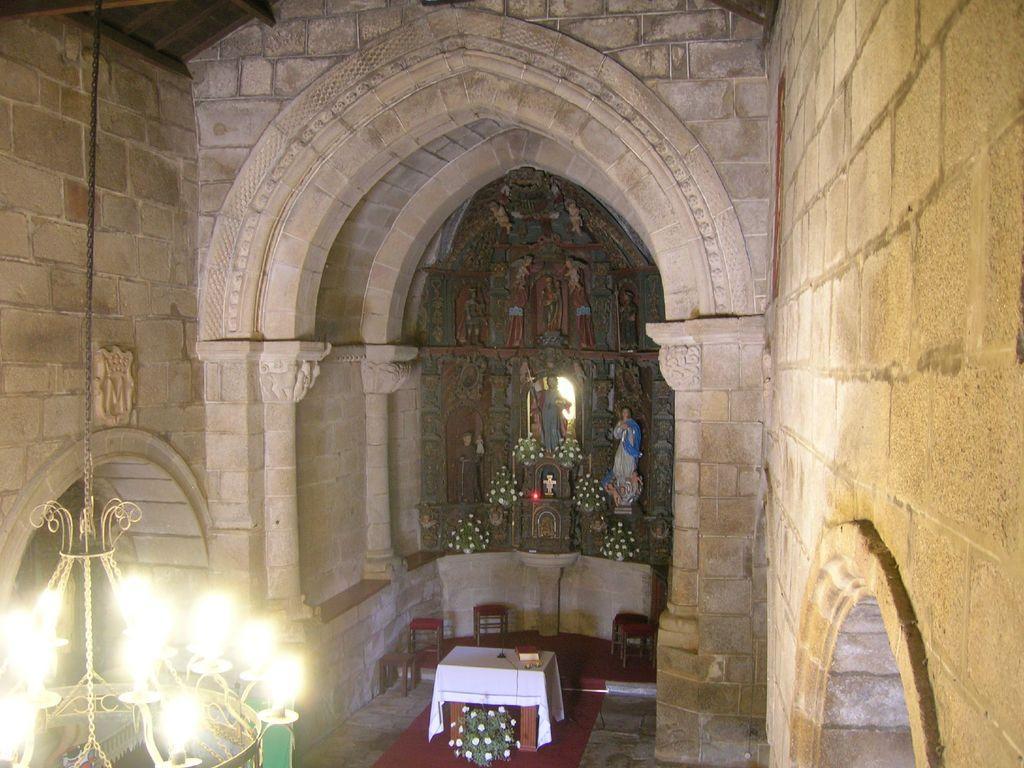Can you describe this image briefly? This is inside a building. In this building there are brick walls, arches, chandeliers. Also there are stools, table with tablecloth, statues, flower bouquets. On the table there is a book and some other items. 